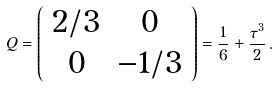Convert formula to latex. <formula><loc_0><loc_0><loc_500><loc_500>Q = \left ( \begin{array} { c c } { 2 / 3 } & { 0 } \\ { 0 } & { - 1 / 3 } \end{array} \right ) = \frac { 1 } { 6 } + \frac { \tau ^ { 3 } } { 2 } \, .</formula> 